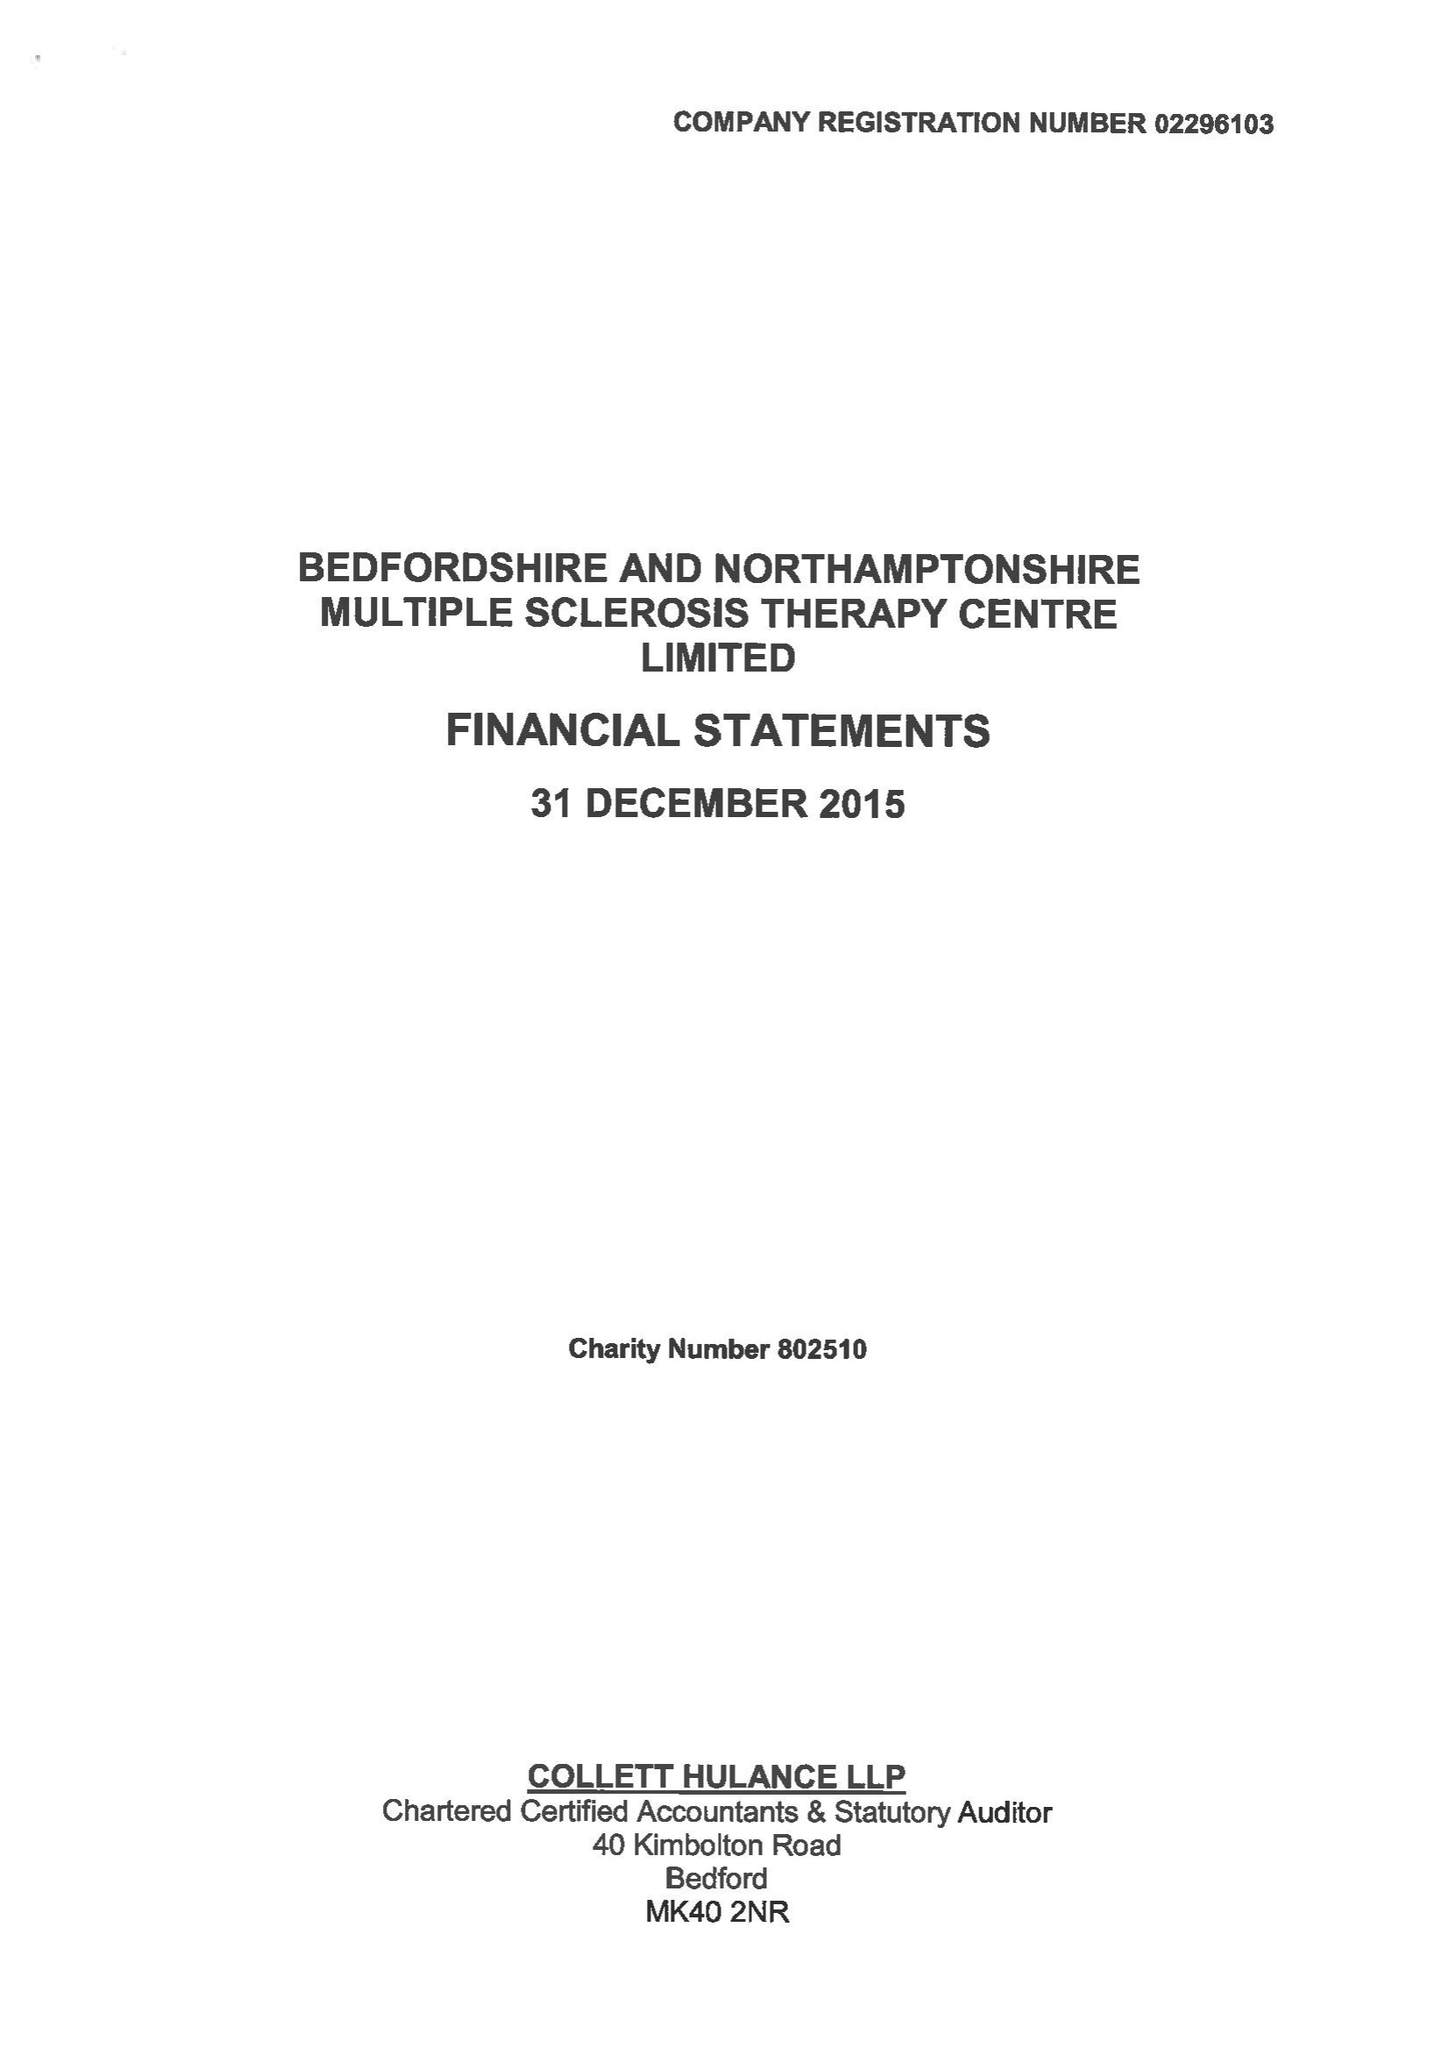What is the value for the address__street_line?
Answer the question using a single word or phrase. BARKERS LANE 